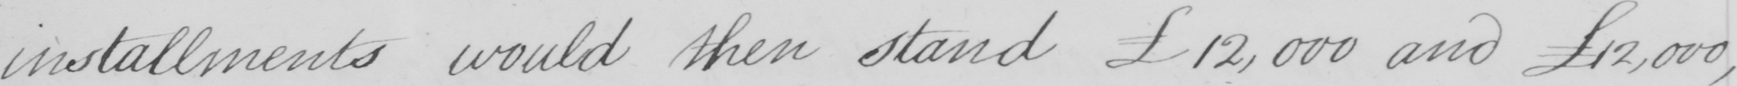What text is written in this handwritten line? installments would then stand £12,000 amd £12,000 , 